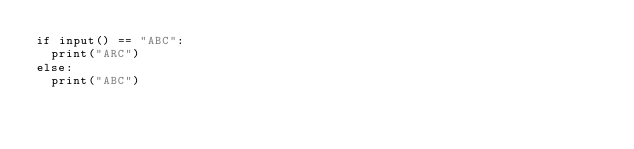<code> <loc_0><loc_0><loc_500><loc_500><_Python_>if input() == "ABC":
  print("ARC")
else:
  print("ABC")</code> 